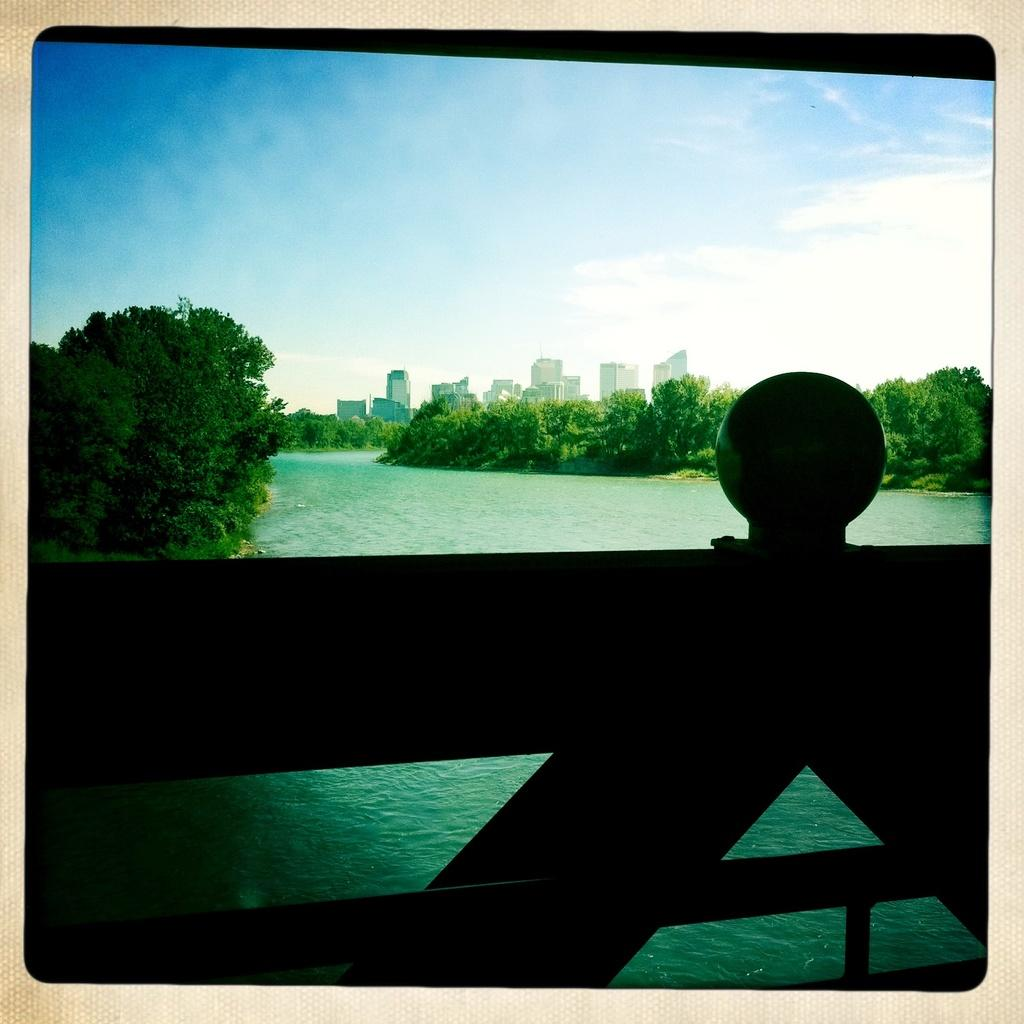What type of structures can be seen in the image? There are buildings in the image. What can be seen above the buildings? The sky is visible in the image, and clouds are present in the sky. What type of vegetation is in the image? There are trees in the image. What is the body of water in the image used for? The water is visible in the image, but its purpose cannot be determined from the image alone. What type of architectural feature is present in the image? There is a bridge in the image. Can you see any guns hanging from the bridge in the image? There are no guns present in the image; it features buildings, the sky, clouds, trees, water, and a bridge. Are there any cobwebs visible on the trees in the image? There is no mention of cobwebs in the provided facts, and therefore it cannot be determined if any are present in the image. 